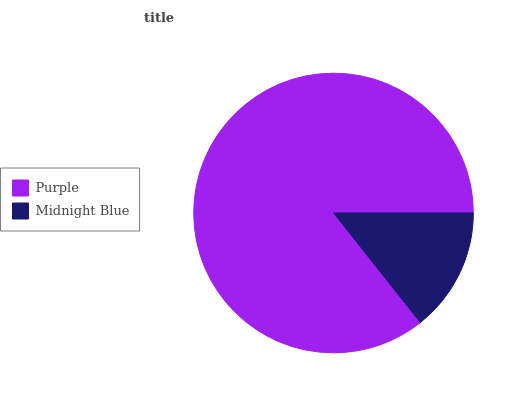Is Midnight Blue the minimum?
Answer yes or no. Yes. Is Purple the maximum?
Answer yes or no. Yes. Is Midnight Blue the maximum?
Answer yes or no. No. Is Purple greater than Midnight Blue?
Answer yes or no. Yes. Is Midnight Blue less than Purple?
Answer yes or no. Yes. Is Midnight Blue greater than Purple?
Answer yes or no. No. Is Purple less than Midnight Blue?
Answer yes or no. No. Is Purple the high median?
Answer yes or no. Yes. Is Midnight Blue the low median?
Answer yes or no. Yes. Is Midnight Blue the high median?
Answer yes or no. No. Is Purple the low median?
Answer yes or no. No. 